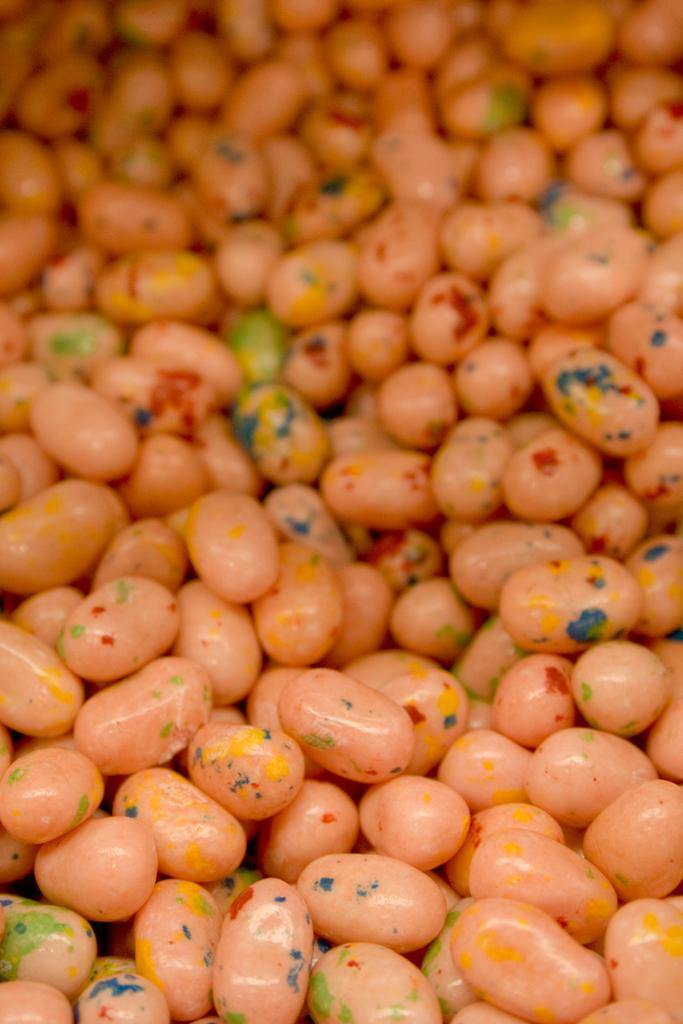What shape is the crook using to teach beginner-level painting in the image? There is no image provided, and therefore no crook, beginner, or painting activity can be observed. 